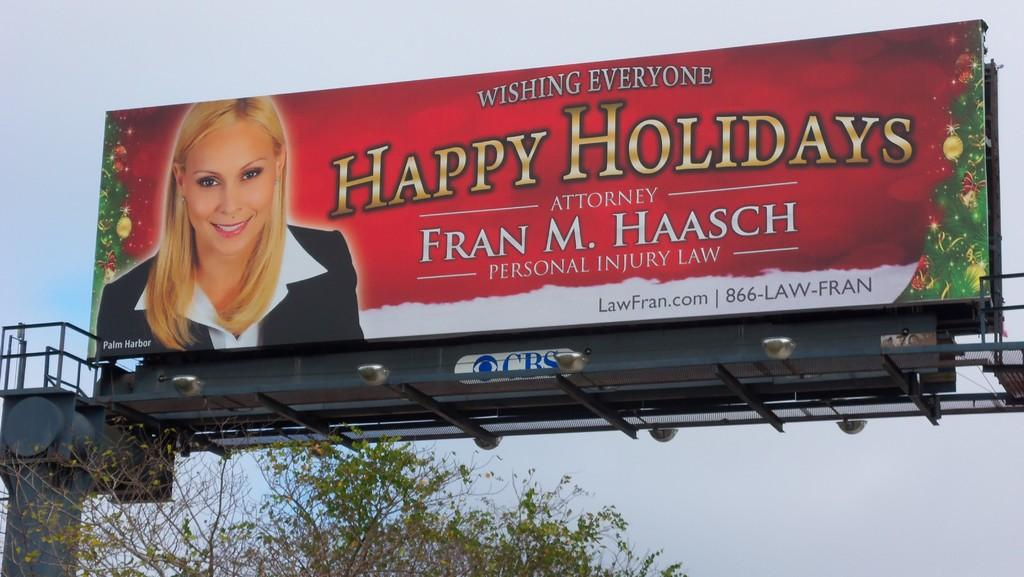<image>
Give a short and clear explanation of the subsequent image. a sign with a as by Fran M. Haasch on it 